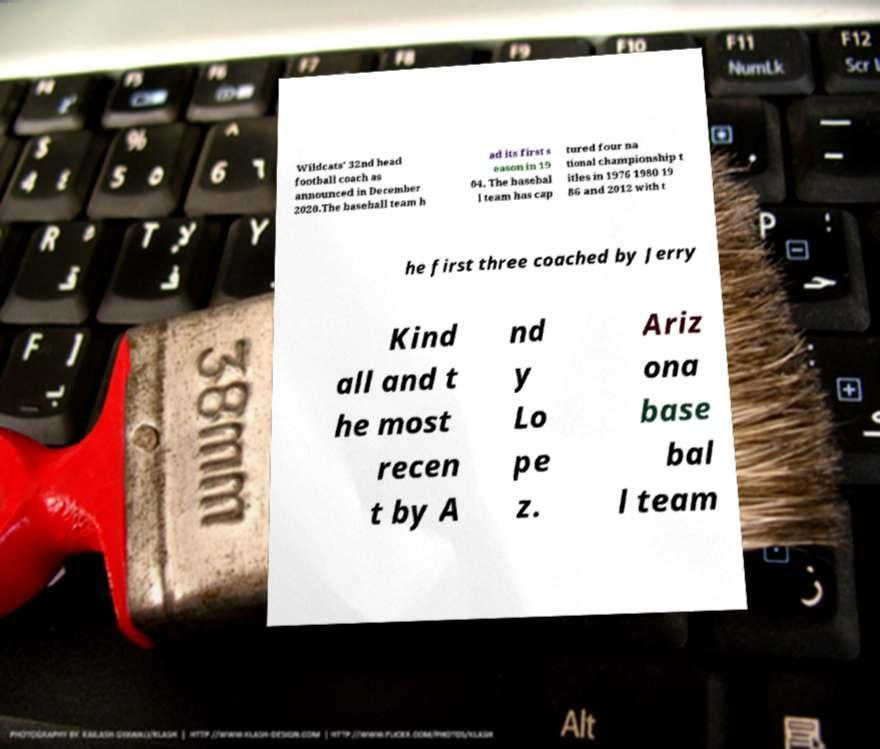Could you extract and type out the text from this image? Wildcats’ 32nd head football coach as announced in December 2020.The baseball team h ad its first s eason in 19 04. The basebal l team has cap tured four na tional championship t itles in 1976 1980 19 86 and 2012 with t he first three coached by Jerry Kind all and t he most recen t by A nd y Lo pe z. Ariz ona base bal l team 